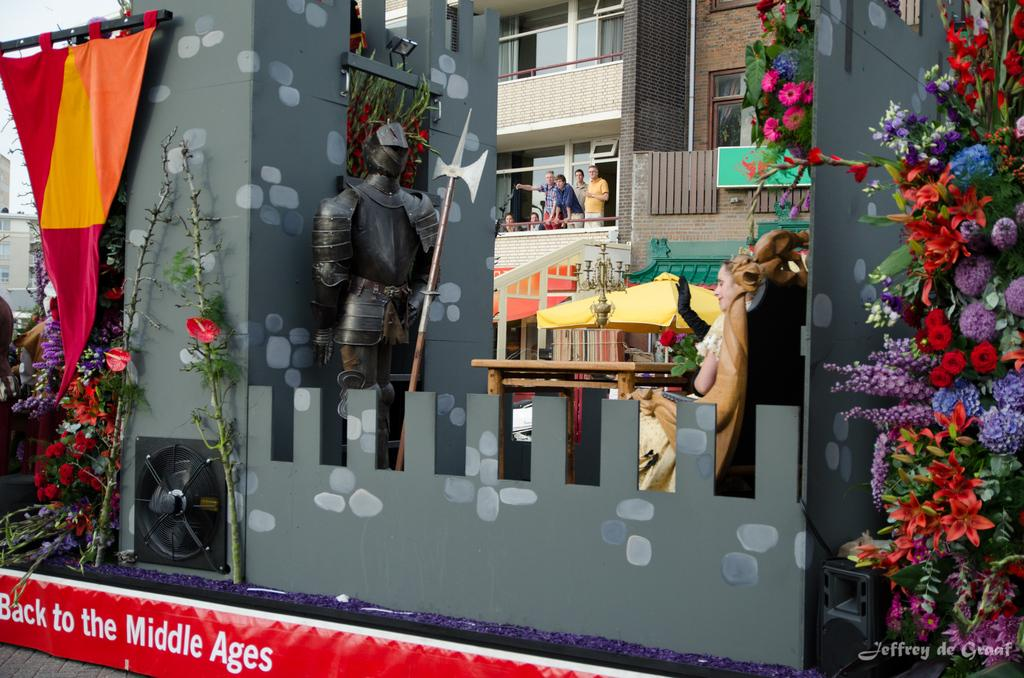Provide a one-sentence caption for the provided image. A storefront with stuff in the window and "Back to the Middle Ages" written below. 